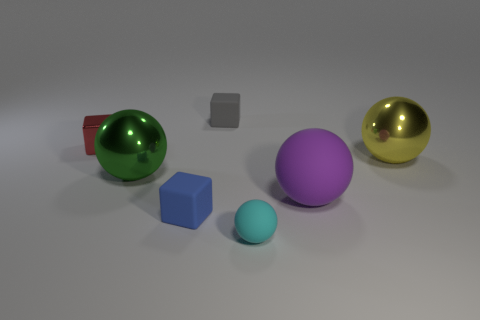How many large balls are both in front of the yellow thing and to the right of the tiny cyan thing?
Offer a terse response. 1. There is a ball that is on the left side of the blue matte block; does it have the same size as the large matte ball?
Your answer should be very brief. Yes. Is there a big object of the same color as the large rubber ball?
Provide a succinct answer. No. What is the size of the blue object that is the same material as the small gray block?
Your answer should be very brief. Small. Is the number of matte balls that are on the left side of the cyan rubber object greater than the number of metallic balls to the right of the small red thing?
Make the answer very short. No. What number of other things are there of the same material as the yellow ball
Provide a succinct answer. 2. Do the block that is in front of the red shiny cube and the gray object have the same material?
Your answer should be very brief. Yes. There is a yellow thing; what shape is it?
Your answer should be very brief. Sphere. Is the number of metallic blocks to the right of the tiny metal object greater than the number of big yellow objects?
Give a very brief answer. No. Are there any other things that are the same shape as the cyan thing?
Offer a terse response. Yes. 